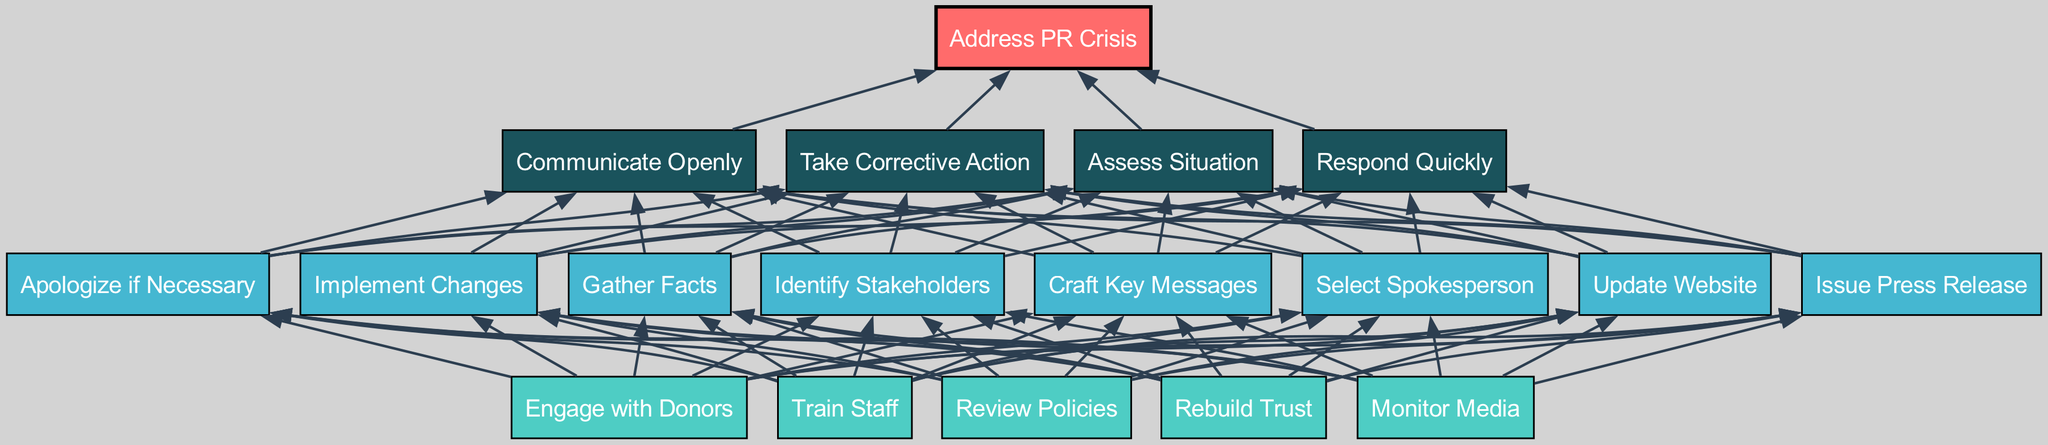What is the root node of the diagram? The root node, which is the topmost element in a flow chart, is explicitly labeled in the diagram as "Address PR Crisis."
Answer: Address PR Crisis How many nodes are there at level 1? By counting the nodes listed in level 1 of the diagram, we can see that there are four nodes present.
Answer: 4 What action should be taken immediately as indicated in the diagram? The first node under level 1 outlines the initial step in addressing the PR crisis, which is "Assess Situation."
Answer: Assess Situation Which nodes are connected directly to the "Respond Quickly" node? By examining the edges in the diagram, we see that "Respond Quickly" directly connects to "Gather Facts," "Update Website," and "Issue Press Release."
Answer: Gather Facts, Update Website, Issue Press Release What is the last step of the diagram in level 3? The last node listed in level 3 indicates the final action for reputation rebuilding, which is "Rebuild Trust."
Answer: Rebuild Trust How many corrective actions are listed in level 2? In level 2, there are four specific actions that can be taken for correction, visible by counting the corresponding nodes.
Answer: 4 What are the main categories of actions listed at level 1? The primary actions categorized at level 1 focus on assessing, responding, communicating, and corrective measures as outlined by the four nodes.
Answer: Assess Situation, Respond Quickly, Communicate Openly, Take Corrective Action Describe the connection between "Take Corrective Action" and "Implement Changes." "Take Corrective Action" is one of the main nodes at level 1, and it is connected to "Implement Changes" at level 2, emphasizing the importance of implementing necessary adjustments in response to the crisis.
Answer: Connected What two groups of stakeholders should be engaged as shown in the diagram? The diagram indicates two key groups for engagement: "Engage with Donors" at level 3 and "Identify Stakeholders" at level 2, highlighting the importance of both donor relationships and stakeholder identification.
Answer: Engage with Donors, Identify Stakeholders 